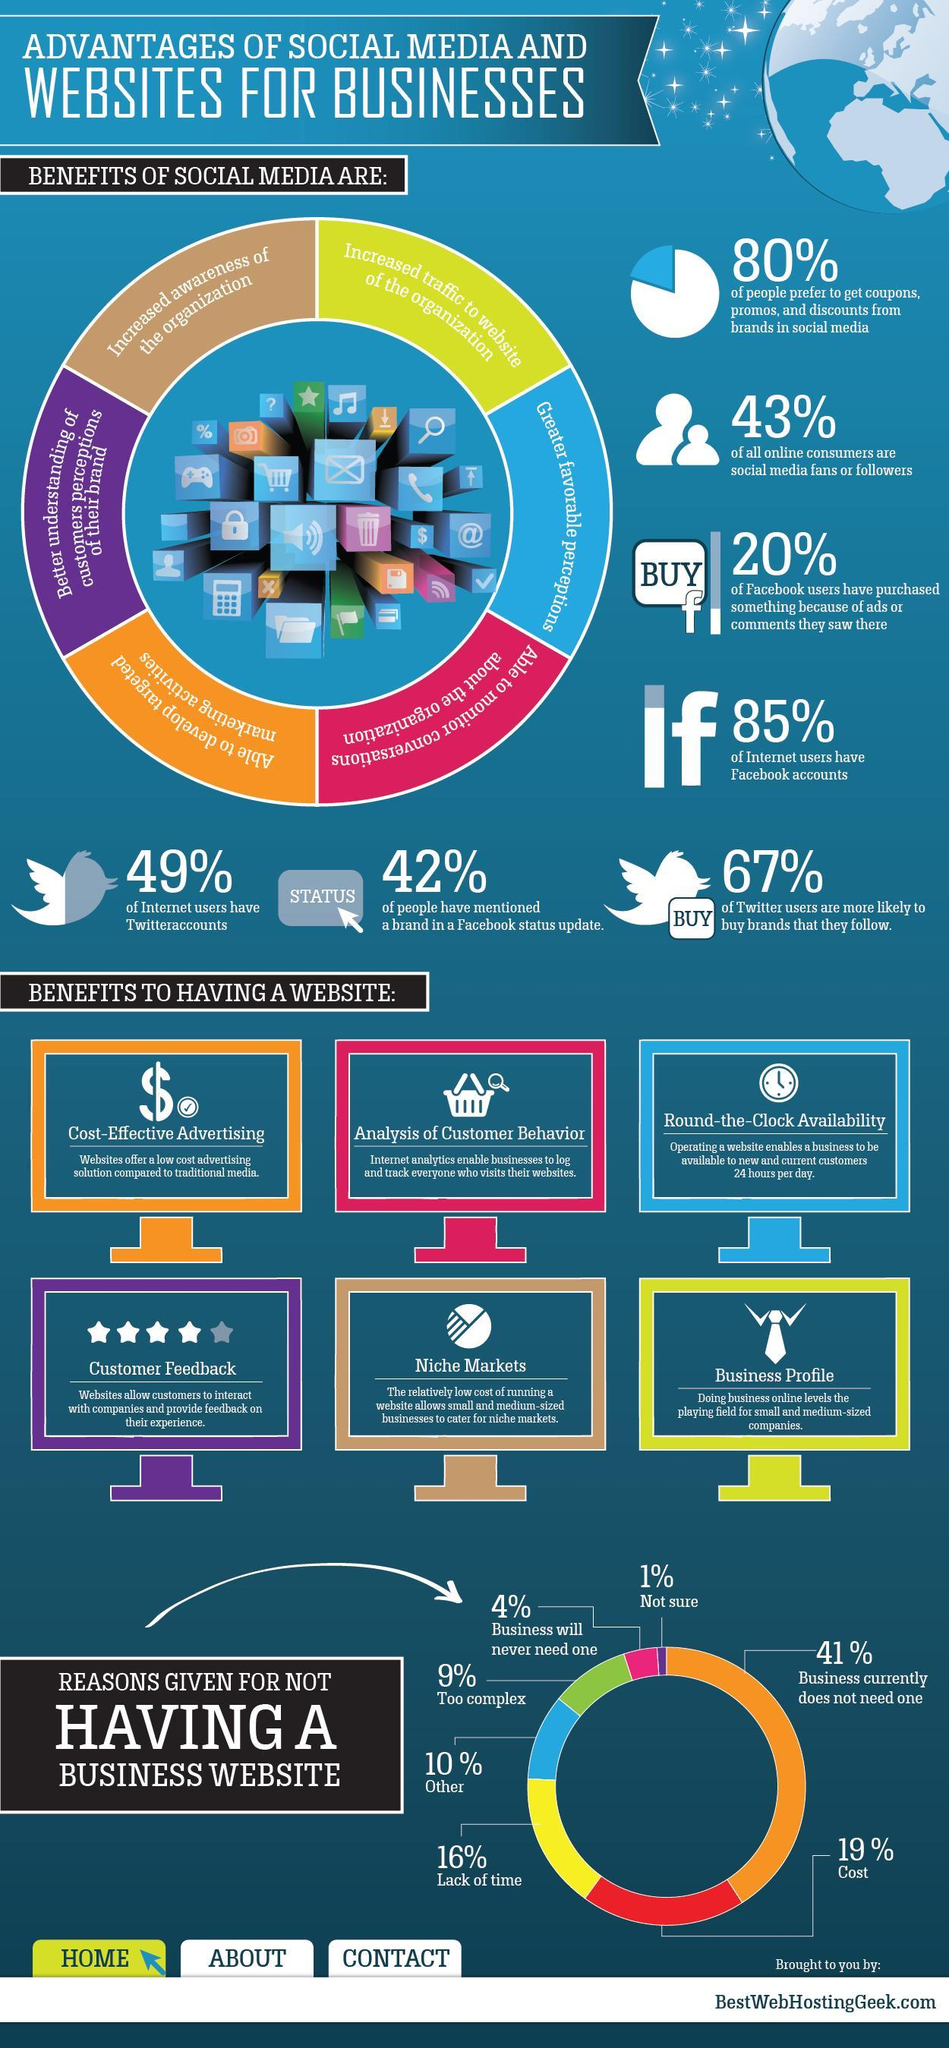Which reason is the top one for not having a business website?
Answer the question with a short phrase. Business currently does not need one How many benefits of having a website are listed? 6 What percent of Facebook users have not purchased anything because of ads or comments? 80% What percent think that having a website is too complex and that business will never need one? 13% What percent of people do not prefer coupons or promos from brands in social media? 20% 